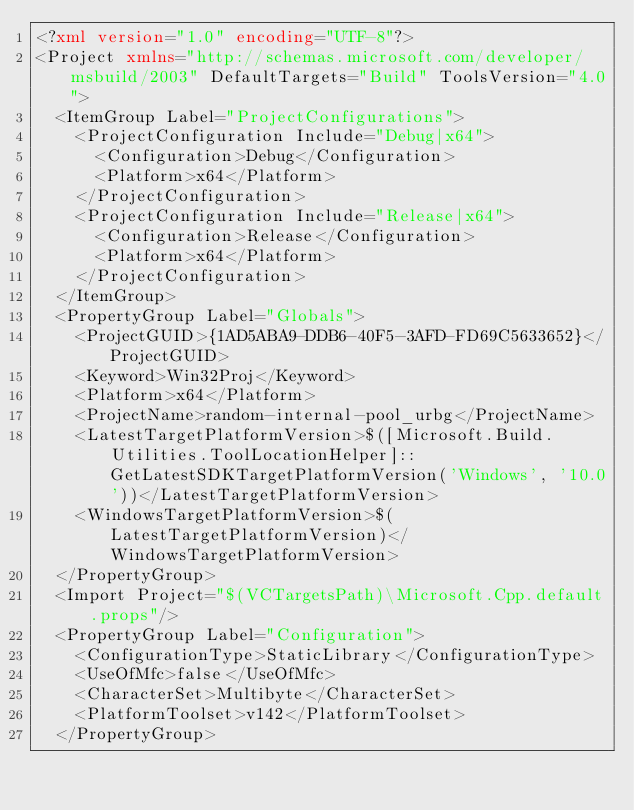Convert code to text. <code><loc_0><loc_0><loc_500><loc_500><_XML_><?xml version="1.0" encoding="UTF-8"?>
<Project xmlns="http://schemas.microsoft.com/developer/msbuild/2003" DefaultTargets="Build" ToolsVersion="4.0">
  <ItemGroup Label="ProjectConfigurations">
    <ProjectConfiguration Include="Debug|x64">
      <Configuration>Debug</Configuration>
      <Platform>x64</Platform>
    </ProjectConfiguration>
    <ProjectConfiguration Include="Release|x64">
      <Configuration>Release</Configuration>
      <Platform>x64</Platform>
    </ProjectConfiguration>
  </ItemGroup>
  <PropertyGroup Label="Globals">
    <ProjectGUID>{1AD5ABA9-DDB6-40F5-3AFD-FD69C5633652}</ProjectGUID>
    <Keyword>Win32Proj</Keyword>
    <Platform>x64</Platform>
    <ProjectName>random-internal-pool_urbg</ProjectName>
    <LatestTargetPlatformVersion>$([Microsoft.Build.Utilities.ToolLocationHelper]::GetLatestSDKTargetPlatformVersion('Windows', '10.0'))</LatestTargetPlatformVersion>
    <WindowsTargetPlatformVersion>$(LatestTargetPlatformVersion)</WindowsTargetPlatformVersion>
  </PropertyGroup>
  <Import Project="$(VCTargetsPath)\Microsoft.Cpp.default.props"/>
  <PropertyGroup Label="Configuration">
    <ConfigurationType>StaticLibrary</ConfigurationType>
    <UseOfMfc>false</UseOfMfc>
    <CharacterSet>Multibyte</CharacterSet>
    <PlatformToolset>v142</PlatformToolset>
  </PropertyGroup></code> 